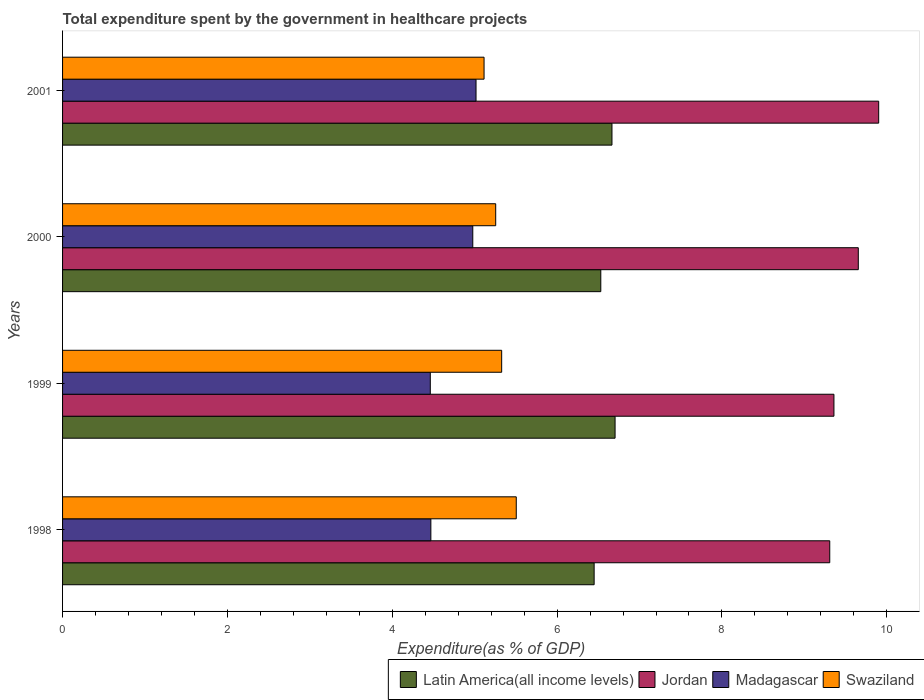How many groups of bars are there?
Offer a terse response. 4. How many bars are there on the 4th tick from the top?
Give a very brief answer. 4. How many bars are there on the 4th tick from the bottom?
Your answer should be compact. 4. In how many cases, is the number of bars for a given year not equal to the number of legend labels?
Your answer should be compact. 0. What is the total expenditure spent by the government in healthcare projects in Latin America(all income levels) in 2000?
Make the answer very short. 6.53. Across all years, what is the maximum total expenditure spent by the government in healthcare projects in Madagascar?
Your answer should be compact. 5.02. Across all years, what is the minimum total expenditure spent by the government in healthcare projects in Madagascar?
Keep it short and to the point. 4.46. In which year was the total expenditure spent by the government in healthcare projects in Swaziland minimum?
Ensure brevity in your answer.  2001. What is the total total expenditure spent by the government in healthcare projects in Latin America(all income levels) in the graph?
Keep it short and to the point. 26.35. What is the difference between the total expenditure spent by the government in healthcare projects in Madagascar in 1999 and that in 2001?
Offer a very short reply. -0.55. What is the difference between the total expenditure spent by the government in healthcare projects in Latin America(all income levels) in 1998 and the total expenditure spent by the government in healthcare projects in Swaziland in 1999?
Give a very brief answer. 1.12. What is the average total expenditure spent by the government in healthcare projects in Madagascar per year?
Your answer should be very brief. 4.73. In the year 1999, what is the difference between the total expenditure spent by the government in healthcare projects in Swaziland and total expenditure spent by the government in healthcare projects in Jordan?
Give a very brief answer. -4.03. In how many years, is the total expenditure spent by the government in healthcare projects in Madagascar greater than 2 %?
Provide a short and direct response. 4. What is the ratio of the total expenditure spent by the government in healthcare projects in Swaziland in 1999 to that in 2001?
Your response must be concise. 1.04. Is the total expenditure spent by the government in healthcare projects in Madagascar in 1999 less than that in 2000?
Provide a short and direct response. Yes. What is the difference between the highest and the second highest total expenditure spent by the government in healthcare projects in Madagascar?
Provide a short and direct response. 0.04. What is the difference between the highest and the lowest total expenditure spent by the government in healthcare projects in Swaziland?
Ensure brevity in your answer.  0.39. What does the 3rd bar from the top in 1998 represents?
Your answer should be very brief. Jordan. What does the 1st bar from the bottom in 2000 represents?
Your response must be concise. Latin America(all income levels). How many bars are there?
Provide a short and direct response. 16. What is the difference between two consecutive major ticks on the X-axis?
Provide a short and direct response. 2. Are the values on the major ticks of X-axis written in scientific E-notation?
Ensure brevity in your answer.  No. How are the legend labels stacked?
Your response must be concise. Horizontal. What is the title of the graph?
Offer a terse response. Total expenditure spent by the government in healthcare projects. Does "Uruguay" appear as one of the legend labels in the graph?
Your response must be concise. No. What is the label or title of the X-axis?
Offer a terse response. Expenditure(as % of GDP). What is the Expenditure(as % of GDP) of Latin America(all income levels) in 1998?
Offer a very short reply. 6.45. What is the Expenditure(as % of GDP) in Jordan in 1998?
Your answer should be compact. 9.31. What is the Expenditure(as % of GDP) of Madagascar in 1998?
Make the answer very short. 4.47. What is the Expenditure(as % of GDP) of Swaziland in 1998?
Your answer should be very brief. 5.5. What is the Expenditure(as % of GDP) in Latin America(all income levels) in 1999?
Ensure brevity in your answer.  6.7. What is the Expenditure(as % of GDP) in Jordan in 1999?
Your response must be concise. 9.36. What is the Expenditure(as % of GDP) in Madagascar in 1999?
Give a very brief answer. 4.46. What is the Expenditure(as % of GDP) in Swaziland in 1999?
Give a very brief answer. 5.33. What is the Expenditure(as % of GDP) of Latin America(all income levels) in 2000?
Keep it short and to the point. 6.53. What is the Expenditure(as % of GDP) of Jordan in 2000?
Give a very brief answer. 9.65. What is the Expenditure(as % of GDP) in Madagascar in 2000?
Give a very brief answer. 4.98. What is the Expenditure(as % of GDP) of Swaziland in 2000?
Keep it short and to the point. 5.26. What is the Expenditure(as % of GDP) in Latin America(all income levels) in 2001?
Provide a short and direct response. 6.67. What is the Expenditure(as % of GDP) in Jordan in 2001?
Your answer should be compact. 9.9. What is the Expenditure(as % of GDP) in Madagascar in 2001?
Keep it short and to the point. 5.02. What is the Expenditure(as % of GDP) of Swaziland in 2001?
Keep it short and to the point. 5.11. Across all years, what is the maximum Expenditure(as % of GDP) of Latin America(all income levels)?
Provide a succinct answer. 6.7. Across all years, what is the maximum Expenditure(as % of GDP) of Jordan?
Provide a succinct answer. 9.9. Across all years, what is the maximum Expenditure(as % of GDP) of Madagascar?
Your answer should be compact. 5.02. Across all years, what is the maximum Expenditure(as % of GDP) of Swaziland?
Ensure brevity in your answer.  5.5. Across all years, what is the minimum Expenditure(as % of GDP) in Latin America(all income levels)?
Provide a short and direct response. 6.45. Across all years, what is the minimum Expenditure(as % of GDP) in Jordan?
Give a very brief answer. 9.31. Across all years, what is the minimum Expenditure(as % of GDP) in Madagascar?
Provide a short and direct response. 4.46. Across all years, what is the minimum Expenditure(as % of GDP) of Swaziland?
Your answer should be very brief. 5.11. What is the total Expenditure(as % of GDP) in Latin America(all income levels) in the graph?
Offer a very short reply. 26.35. What is the total Expenditure(as % of GDP) in Jordan in the graph?
Provide a short and direct response. 38.22. What is the total Expenditure(as % of GDP) of Madagascar in the graph?
Keep it short and to the point. 18.92. What is the total Expenditure(as % of GDP) in Swaziland in the graph?
Provide a succinct answer. 21.2. What is the difference between the Expenditure(as % of GDP) in Latin America(all income levels) in 1998 and that in 1999?
Offer a very short reply. -0.25. What is the difference between the Expenditure(as % of GDP) of Jordan in 1998 and that in 1999?
Ensure brevity in your answer.  -0.05. What is the difference between the Expenditure(as % of GDP) of Madagascar in 1998 and that in 1999?
Your answer should be compact. 0.01. What is the difference between the Expenditure(as % of GDP) of Swaziland in 1998 and that in 1999?
Your answer should be very brief. 0.18. What is the difference between the Expenditure(as % of GDP) of Latin America(all income levels) in 1998 and that in 2000?
Your answer should be very brief. -0.08. What is the difference between the Expenditure(as % of GDP) of Jordan in 1998 and that in 2000?
Your answer should be compact. -0.35. What is the difference between the Expenditure(as % of GDP) of Madagascar in 1998 and that in 2000?
Keep it short and to the point. -0.51. What is the difference between the Expenditure(as % of GDP) of Swaziland in 1998 and that in 2000?
Give a very brief answer. 0.25. What is the difference between the Expenditure(as % of GDP) of Latin America(all income levels) in 1998 and that in 2001?
Your response must be concise. -0.22. What is the difference between the Expenditure(as % of GDP) in Jordan in 1998 and that in 2001?
Make the answer very short. -0.59. What is the difference between the Expenditure(as % of GDP) in Madagascar in 1998 and that in 2001?
Provide a short and direct response. -0.55. What is the difference between the Expenditure(as % of GDP) in Swaziland in 1998 and that in 2001?
Your response must be concise. 0.39. What is the difference between the Expenditure(as % of GDP) in Latin America(all income levels) in 1999 and that in 2000?
Offer a very short reply. 0.17. What is the difference between the Expenditure(as % of GDP) in Jordan in 1999 and that in 2000?
Keep it short and to the point. -0.3. What is the difference between the Expenditure(as % of GDP) of Madagascar in 1999 and that in 2000?
Your answer should be very brief. -0.52. What is the difference between the Expenditure(as % of GDP) in Swaziland in 1999 and that in 2000?
Provide a succinct answer. 0.07. What is the difference between the Expenditure(as % of GDP) in Latin America(all income levels) in 1999 and that in 2001?
Keep it short and to the point. 0.04. What is the difference between the Expenditure(as % of GDP) of Jordan in 1999 and that in 2001?
Give a very brief answer. -0.54. What is the difference between the Expenditure(as % of GDP) in Madagascar in 1999 and that in 2001?
Your response must be concise. -0.55. What is the difference between the Expenditure(as % of GDP) of Swaziland in 1999 and that in 2001?
Make the answer very short. 0.21. What is the difference between the Expenditure(as % of GDP) in Latin America(all income levels) in 2000 and that in 2001?
Provide a short and direct response. -0.14. What is the difference between the Expenditure(as % of GDP) in Jordan in 2000 and that in 2001?
Offer a very short reply. -0.25. What is the difference between the Expenditure(as % of GDP) of Madagascar in 2000 and that in 2001?
Ensure brevity in your answer.  -0.04. What is the difference between the Expenditure(as % of GDP) of Swaziland in 2000 and that in 2001?
Your answer should be compact. 0.14. What is the difference between the Expenditure(as % of GDP) of Latin America(all income levels) in 1998 and the Expenditure(as % of GDP) of Jordan in 1999?
Offer a very short reply. -2.91. What is the difference between the Expenditure(as % of GDP) in Latin America(all income levels) in 1998 and the Expenditure(as % of GDP) in Madagascar in 1999?
Give a very brief answer. 1.99. What is the difference between the Expenditure(as % of GDP) of Latin America(all income levels) in 1998 and the Expenditure(as % of GDP) of Swaziland in 1999?
Make the answer very short. 1.12. What is the difference between the Expenditure(as % of GDP) of Jordan in 1998 and the Expenditure(as % of GDP) of Madagascar in 1999?
Give a very brief answer. 4.85. What is the difference between the Expenditure(as % of GDP) in Jordan in 1998 and the Expenditure(as % of GDP) in Swaziland in 1999?
Offer a terse response. 3.98. What is the difference between the Expenditure(as % of GDP) in Madagascar in 1998 and the Expenditure(as % of GDP) in Swaziland in 1999?
Your response must be concise. -0.86. What is the difference between the Expenditure(as % of GDP) in Latin America(all income levels) in 1998 and the Expenditure(as % of GDP) in Jordan in 2000?
Ensure brevity in your answer.  -3.21. What is the difference between the Expenditure(as % of GDP) in Latin America(all income levels) in 1998 and the Expenditure(as % of GDP) in Madagascar in 2000?
Offer a terse response. 1.47. What is the difference between the Expenditure(as % of GDP) of Latin America(all income levels) in 1998 and the Expenditure(as % of GDP) of Swaziland in 2000?
Make the answer very short. 1.19. What is the difference between the Expenditure(as % of GDP) of Jordan in 1998 and the Expenditure(as % of GDP) of Madagascar in 2000?
Provide a succinct answer. 4.33. What is the difference between the Expenditure(as % of GDP) in Jordan in 1998 and the Expenditure(as % of GDP) in Swaziland in 2000?
Your response must be concise. 4.05. What is the difference between the Expenditure(as % of GDP) in Madagascar in 1998 and the Expenditure(as % of GDP) in Swaziland in 2000?
Your answer should be very brief. -0.79. What is the difference between the Expenditure(as % of GDP) in Latin America(all income levels) in 1998 and the Expenditure(as % of GDP) in Jordan in 2001?
Your answer should be very brief. -3.45. What is the difference between the Expenditure(as % of GDP) in Latin America(all income levels) in 1998 and the Expenditure(as % of GDP) in Madagascar in 2001?
Your answer should be compact. 1.43. What is the difference between the Expenditure(as % of GDP) in Latin America(all income levels) in 1998 and the Expenditure(as % of GDP) in Swaziland in 2001?
Keep it short and to the point. 1.34. What is the difference between the Expenditure(as % of GDP) in Jordan in 1998 and the Expenditure(as % of GDP) in Madagascar in 2001?
Give a very brief answer. 4.29. What is the difference between the Expenditure(as % of GDP) in Jordan in 1998 and the Expenditure(as % of GDP) in Swaziland in 2001?
Keep it short and to the point. 4.19. What is the difference between the Expenditure(as % of GDP) in Madagascar in 1998 and the Expenditure(as % of GDP) in Swaziland in 2001?
Keep it short and to the point. -0.65. What is the difference between the Expenditure(as % of GDP) of Latin America(all income levels) in 1999 and the Expenditure(as % of GDP) of Jordan in 2000?
Offer a terse response. -2.95. What is the difference between the Expenditure(as % of GDP) of Latin America(all income levels) in 1999 and the Expenditure(as % of GDP) of Madagascar in 2000?
Your response must be concise. 1.73. What is the difference between the Expenditure(as % of GDP) in Latin America(all income levels) in 1999 and the Expenditure(as % of GDP) in Swaziland in 2000?
Ensure brevity in your answer.  1.45. What is the difference between the Expenditure(as % of GDP) of Jordan in 1999 and the Expenditure(as % of GDP) of Madagascar in 2000?
Your response must be concise. 4.38. What is the difference between the Expenditure(as % of GDP) of Jordan in 1999 and the Expenditure(as % of GDP) of Swaziland in 2000?
Offer a terse response. 4.1. What is the difference between the Expenditure(as % of GDP) in Madagascar in 1999 and the Expenditure(as % of GDP) in Swaziland in 2000?
Offer a very short reply. -0.79. What is the difference between the Expenditure(as % of GDP) of Latin America(all income levels) in 1999 and the Expenditure(as % of GDP) of Jordan in 2001?
Your answer should be very brief. -3.2. What is the difference between the Expenditure(as % of GDP) of Latin America(all income levels) in 1999 and the Expenditure(as % of GDP) of Madagascar in 2001?
Offer a terse response. 1.69. What is the difference between the Expenditure(as % of GDP) of Latin America(all income levels) in 1999 and the Expenditure(as % of GDP) of Swaziland in 2001?
Your answer should be very brief. 1.59. What is the difference between the Expenditure(as % of GDP) in Jordan in 1999 and the Expenditure(as % of GDP) in Madagascar in 2001?
Your answer should be very brief. 4.34. What is the difference between the Expenditure(as % of GDP) in Jordan in 1999 and the Expenditure(as % of GDP) in Swaziland in 2001?
Keep it short and to the point. 4.24. What is the difference between the Expenditure(as % of GDP) of Madagascar in 1999 and the Expenditure(as % of GDP) of Swaziland in 2001?
Your answer should be very brief. -0.65. What is the difference between the Expenditure(as % of GDP) of Latin America(all income levels) in 2000 and the Expenditure(as % of GDP) of Jordan in 2001?
Make the answer very short. -3.37. What is the difference between the Expenditure(as % of GDP) in Latin America(all income levels) in 2000 and the Expenditure(as % of GDP) in Madagascar in 2001?
Ensure brevity in your answer.  1.51. What is the difference between the Expenditure(as % of GDP) of Latin America(all income levels) in 2000 and the Expenditure(as % of GDP) of Swaziland in 2001?
Provide a short and direct response. 1.42. What is the difference between the Expenditure(as % of GDP) of Jordan in 2000 and the Expenditure(as % of GDP) of Madagascar in 2001?
Offer a very short reply. 4.64. What is the difference between the Expenditure(as % of GDP) in Jordan in 2000 and the Expenditure(as % of GDP) in Swaziland in 2001?
Offer a very short reply. 4.54. What is the difference between the Expenditure(as % of GDP) in Madagascar in 2000 and the Expenditure(as % of GDP) in Swaziland in 2001?
Offer a very short reply. -0.14. What is the average Expenditure(as % of GDP) of Latin America(all income levels) per year?
Offer a terse response. 6.59. What is the average Expenditure(as % of GDP) in Jordan per year?
Provide a succinct answer. 9.56. What is the average Expenditure(as % of GDP) of Madagascar per year?
Make the answer very short. 4.73. What is the average Expenditure(as % of GDP) in Swaziland per year?
Make the answer very short. 5.3. In the year 1998, what is the difference between the Expenditure(as % of GDP) in Latin America(all income levels) and Expenditure(as % of GDP) in Jordan?
Provide a short and direct response. -2.86. In the year 1998, what is the difference between the Expenditure(as % of GDP) of Latin America(all income levels) and Expenditure(as % of GDP) of Madagascar?
Provide a short and direct response. 1.98. In the year 1998, what is the difference between the Expenditure(as % of GDP) in Latin America(all income levels) and Expenditure(as % of GDP) in Swaziland?
Offer a terse response. 0.94. In the year 1998, what is the difference between the Expenditure(as % of GDP) in Jordan and Expenditure(as % of GDP) in Madagascar?
Your response must be concise. 4.84. In the year 1998, what is the difference between the Expenditure(as % of GDP) in Jordan and Expenditure(as % of GDP) in Swaziland?
Offer a terse response. 3.8. In the year 1998, what is the difference between the Expenditure(as % of GDP) of Madagascar and Expenditure(as % of GDP) of Swaziland?
Offer a terse response. -1.04. In the year 1999, what is the difference between the Expenditure(as % of GDP) in Latin America(all income levels) and Expenditure(as % of GDP) in Jordan?
Make the answer very short. -2.66. In the year 1999, what is the difference between the Expenditure(as % of GDP) in Latin America(all income levels) and Expenditure(as % of GDP) in Madagascar?
Keep it short and to the point. 2.24. In the year 1999, what is the difference between the Expenditure(as % of GDP) of Latin America(all income levels) and Expenditure(as % of GDP) of Swaziland?
Your answer should be compact. 1.38. In the year 1999, what is the difference between the Expenditure(as % of GDP) of Jordan and Expenditure(as % of GDP) of Madagascar?
Keep it short and to the point. 4.9. In the year 1999, what is the difference between the Expenditure(as % of GDP) of Jordan and Expenditure(as % of GDP) of Swaziland?
Offer a very short reply. 4.03. In the year 1999, what is the difference between the Expenditure(as % of GDP) of Madagascar and Expenditure(as % of GDP) of Swaziland?
Provide a short and direct response. -0.87. In the year 2000, what is the difference between the Expenditure(as % of GDP) in Latin America(all income levels) and Expenditure(as % of GDP) in Jordan?
Ensure brevity in your answer.  -3.12. In the year 2000, what is the difference between the Expenditure(as % of GDP) in Latin America(all income levels) and Expenditure(as % of GDP) in Madagascar?
Your answer should be very brief. 1.55. In the year 2000, what is the difference between the Expenditure(as % of GDP) in Latin America(all income levels) and Expenditure(as % of GDP) in Swaziland?
Provide a short and direct response. 1.28. In the year 2000, what is the difference between the Expenditure(as % of GDP) of Jordan and Expenditure(as % of GDP) of Madagascar?
Offer a terse response. 4.68. In the year 2000, what is the difference between the Expenditure(as % of GDP) of Jordan and Expenditure(as % of GDP) of Swaziland?
Offer a very short reply. 4.4. In the year 2000, what is the difference between the Expenditure(as % of GDP) in Madagascar and Expenditure(as % of GDP) in Swaziland?
Ensure brevity in your answer.  -0.28. In the year 2001, what is the difference between the Expenditure(as % of GDP) of Latin America(all income levels) and Expenditure(as % of GDP) of Jordan?
Make the answer very short. -3.24. In the year 2001, what is the difference between the Expenditure(as % of GDP) in Latin America(all income levels) and Expenditure(as % of GDP) in Madagascar?
Provide a succinct answer. 1.65. In the year 2001, what is the difference between the Expenditure(as % of GDP) in Latin America(all income levels) and Expenditure(as % of GDP) in Swaziland?
Your answer should be compact. 1.55. In the year 2001, what is the difference between the Expenditure(as % of GDP) of Jordan and Expenditure(as % of GDP) of Madagascar?
Offer a terse response. 4.89. In the year 2001, what is the difference between the Expenditure(as % of GDP) of Jordan and Expenditure(as % of GDP) of Swaziland?
Make the answer very short. 4.79. In the year 2001, what is the difference between the Expenditure(as % of GDP) in Madagascar and Expenditure(as % of GDP) in Swaziland?
Provide a short and direct response. -0.1. What is the ratio of the Expenditure(as % of GDP) in Latin America(all income levels) in 1998 to that in 1999?
Provide a short and direct response. 0.96. What is the ratio of the Expenditure(as % of GDP) in Jordan in 1998 to that in 1999?
Offer a terse response. 0.99. What is the ratio of the Expenditure(as % of GDP) in Madagascar in 1998 to that in 1999?
Your answer should be very brief. 1. What is the ratio of the Expenditure(as % of GDP) in Swaziland in 1998 to that in 1999?
Offer a terse response. 1.03. What is the ratio of the Expenditure(as % of GDP) of Latin America(all income levels) in 1998 to that in 2000?
Provide a short and direct response. 0.99. What is the ratio of the Expenditure(as % of GDP) in Jordan in 1998 to that in 2000?
Give a very brief answer. 0.96. What is the ratio of the Expenditure(as % of GDP) of Madagascar in 1998 to that in 2000?
Offer a very short reply. 0.9. What is the ratio of the Expenditure(as % of GDP) in Swaziland in 1998 to that in 2000?
Ensure brevity in your answer.  1.05. What is the ratio of the Expenditure(as % of GDP) of Latin America(all income levels) in 1998 to that in 2001?
Keep it short and to the point. 0.97. What is the ratio of the Expenditure(as % of GDP) of Madagascar in 1998 to that in 2001?
Offer a very short reply. 0.89. What is the ratio of the Expenditure(as % of GDP) in Swaziland in 1998 to that in 2001?
Offer a very short reply. 1.08. What is the ratio of the Expenditure(as % of GDP) of Latin America(all income levels) in 1999 to that in 2000?
Ensure brevity in your answer.  1.03. What is the ratio of the Expenditure(as % of GDP) of Jordan in 1999 to that in 2000?
Ensure brevity in your answer.  0.97. What is the ratio of the Expenditure(as % of GDP) of Madagascar in 1999 to that in 2000?
Offer a very short reply. 0.9. What is the ratio of the Expenditure(as % of GDP) of Swaziland in 1999 to that in 2000?
Your answer should be compact. 1.01. What is the ratio of the Expenditure(as % of GDP) of Latin America(all income levels) in 1999 to that in 2001?
Ensure brevity in your answer.  1.01. What is the ratio of the Expenditure(as % of GDP) of Jordan in 1999 to that in 2001?
Give a very brief answer. 0.95. What is the ratio of the Expenditure(as % of GDP) in Madagascar in 1999 to that in 2001?
Provide a short and direct response. 0.89. What is the ratio of the Expenditure(as % of GDP) of Swaziland in 1999 to that in 2001?
Give a very brief answer. 1.04. What is the ratio of the Expenditure(as % of GDP) in Latin America(all income levels) in 2000 to that in 2001?
Your response must be concise. 0.98. What is the ratio of the Expenditure(as % of GDP) in Swaziland in 2000 to that in 2001?
Your answer should be compact. 1.03. What is the difference between the highest and the second highest Expenditure(as % of GDP) of Latin America(all income levels)?
Provide a short and direct response. 0.04. What is the difference between the highest and the second highest Expenditure(as % of GDP) of Jordan?
Your answer should be very brief. 0.25. What is the difference between the highest and the second highest Expenditure(as % of GDP) in Madagascar?
Your response must be concise. 0.04. What is the difference between the highest and the second highest Expenditure(as % of GDP) in Swaziland?
Make the answer very short. 0.18. What is the difference between the highest and the lowest Expenditure(as % of GDP) of Latin America(all income levels)?
Offer a terse response. 0.25. What is the difference between the highest and the lowest Expenditure(as % of GDP) of Jordan?
Provide a short and direct response. 0.59. What is the difference between the highest and the lowest Expenditure(as % of GDP) in Madagascar?
Your response must be concise. 0.55. What is the difference between the highest and the lowest Expenditure(as % of GDP) in Swaziland?
Your response must be concise. 0.39. 